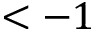<formula> <loc_0><loc_0><loc_500><loc_500>< - 1</formula> 